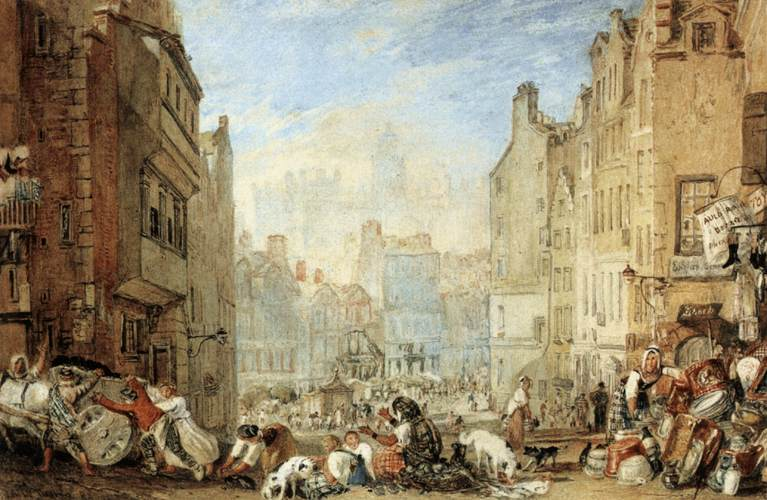What historical period might this image represent, and why? The image likely represents a European city during the late 18th to early 19th century, judging by the style of clothing worn by the people and the architectural designs of the buildings. The presence of market-like activity with goods laid out on the streets, along with the absence of modern transportation, also suggests this time frame. This period is known for its bustling urban centers which were centers of trade and commerce. 